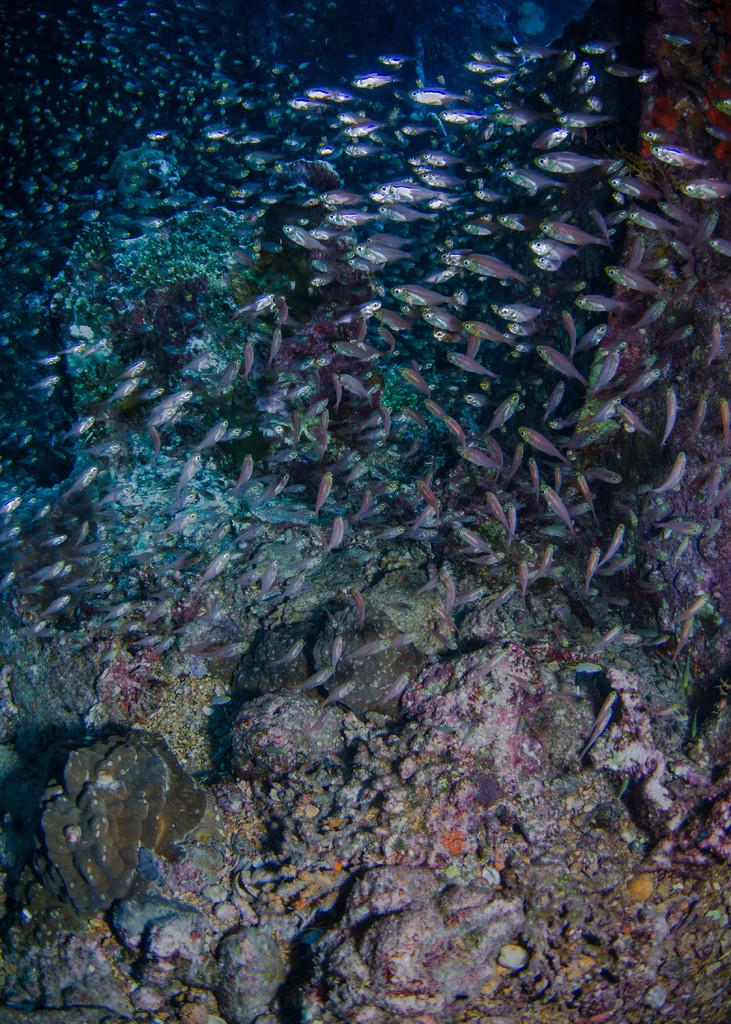Where was the image taken? The image was taken in an ocean. What can be seen in the ocean besides water? There are fishes in the ocean. What is the appearance of the fishes in the image? The fishes are in different colors. What is present at the bottom of the ocean in the image? There are stones at the bottom of the ocean. Can you find the word "spider" written on any of the stones in the image? There is no word "spider" written on any of the stones in the image, as the image only features an ocean, fishes, and stones. 